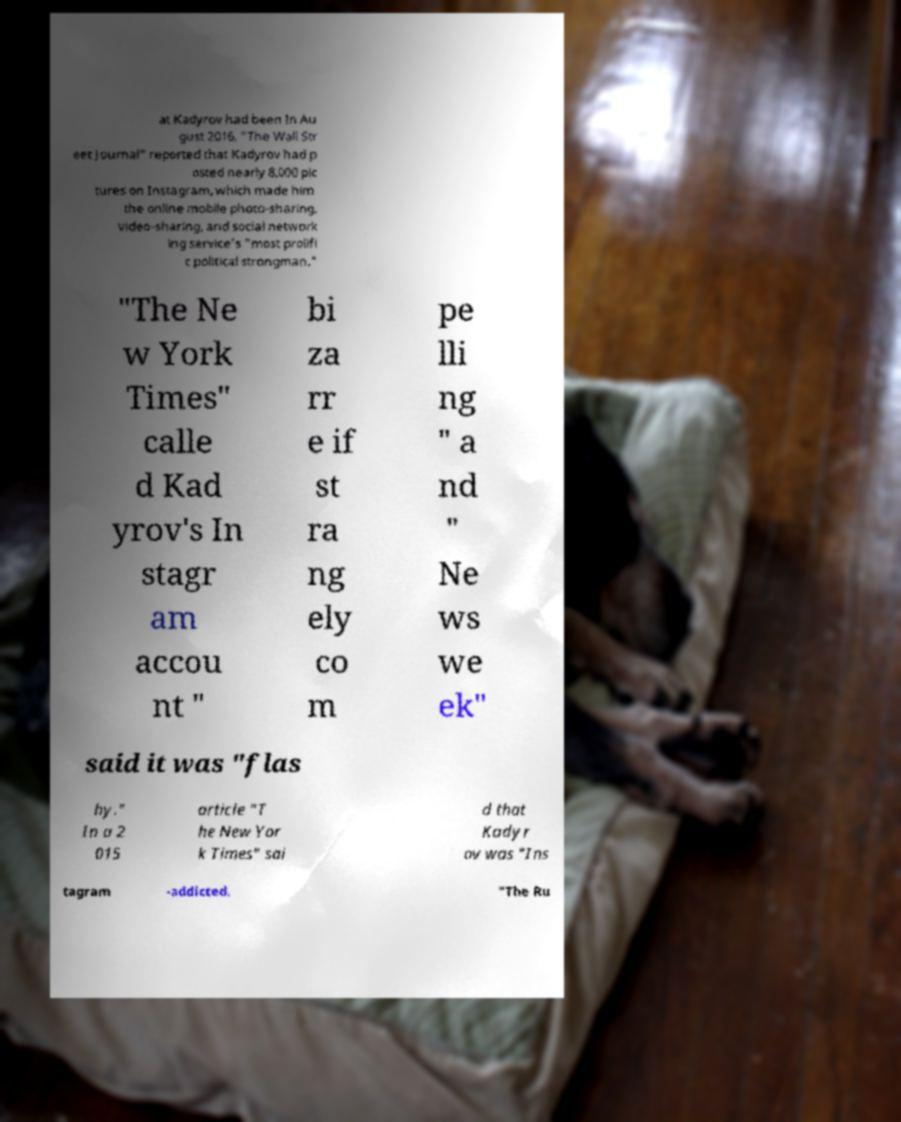Can you accurately transcribe the text from the provided image for me? at Kadyrov had been In Au gust 2016, "The Wall Str eet Journal" reported that Kadyrov had p osted nearly 8,000 pic tures on Instagram, which made him the online mobile photo-sharing, video-sharing, and social network ing service's "most prolifi c political strongman." "The Ne w York Times" calle d Kad yrov's In stagr am accou nt " bi za rr e if st ra ng ely co m pe lli ng " a nd " Ne ws we ek" said it was "flas hy." In a 2 015 article "T he New Yor k Times" sai d that Kadyr ov was "Ins tagram -addicted. "The Ru 